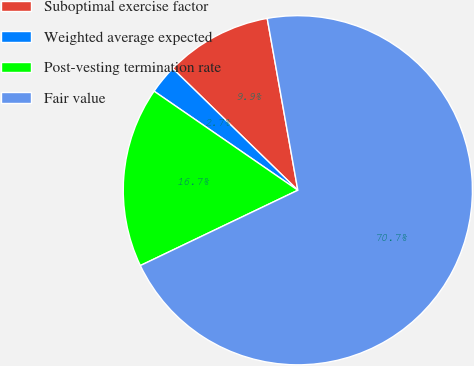Convert chart. <chart><loc_0><loc_0><loc_500><loc_500><pie_chart><fcel>Suboptimal exercise factor<fcel>Weighted average expected<fcel>Post-vesting termination rate<fcel>Fair value<nl><fcel>9.91%<fcel>2.68%<fcel>16.7%<fcel>70.7%<nl></chart> 